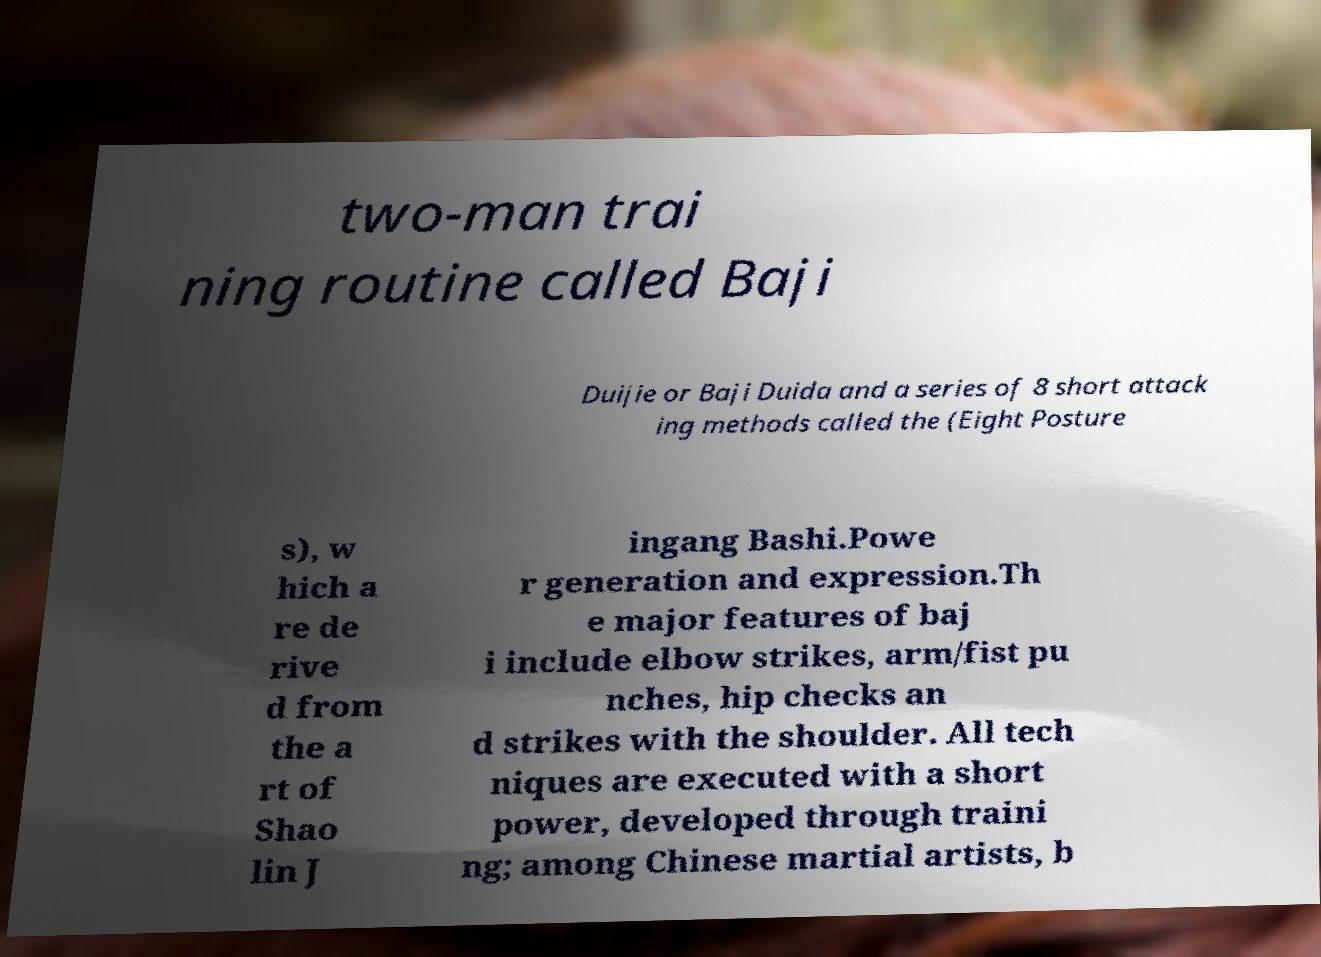I need the written content from this picture converted into text. Can you do that? two-man trai ning routine called Baji Duijie or Baji Duida and a series of 8 short attack ing methods called the (Eight Posture s), w hich a re de rive d from the a rt of Shao lin J ingang Bashi.Powe r generation and expression.Th e major features of baj i include elbow strikes, arm/fist pu nches, hip checks an d strikes with the shoulder. All tech niques are executed with a short power, developed through traini ng; among Chinese martial artists, b 